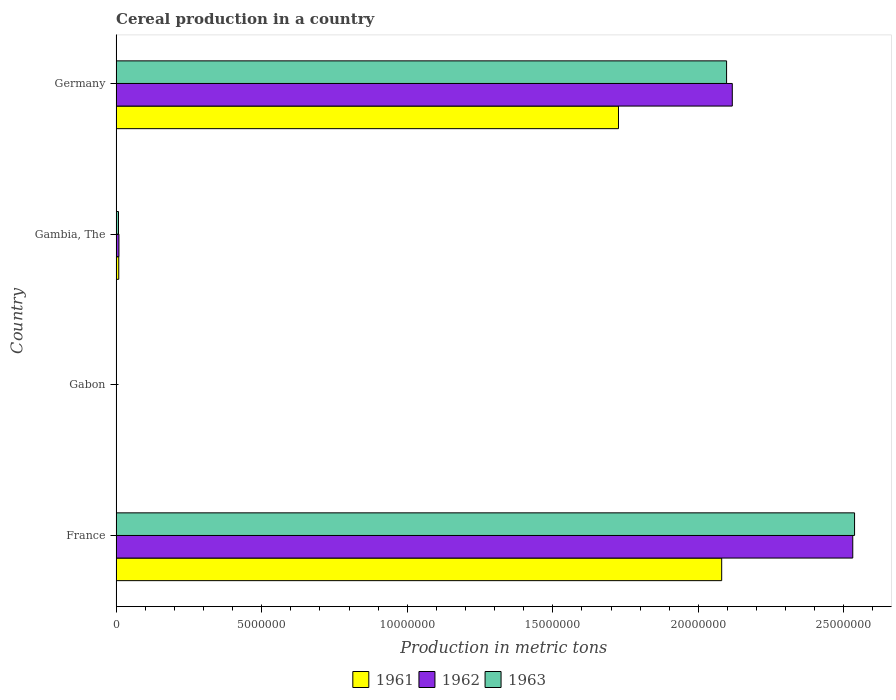How many different coloured bars are there?
Your answer should be compact. 3. Are the number of bars on each tick of the Y-axis equal?
Your answer should be very brief. Yes. How many bars are there on the 2nd tick from the top?
Ensure brevity in your answer.  3. How many bars are there on the 3rd tick from the bottom?
Offer a very short reply. 3. What is the total cereal production in 1963 in Germany?
Offer a very short reply. 2.10e+07. Across all countries, what is the maximum total cereal production in 1962?
Offer a very short reply. 2.53e+07. Across all countries, what is the minimum total cereal production in 1961?
Provide a short and direct response. 9285. In which country was the total cereal production in 1962 minimum?
Make the answer very short. Gabon. What is the total total cereal production in 1963 in the graph?
Offer a terse response. 4.64e+07. What is the difference between the total cereal production in 1961 in France and that in Gambia, The?
Ensure brevity in your answer.  2.07e+07. What is the difference between the total cereal production in 1963 in Germany and the total cereal production in 1961 in France?
Your response must be concise. 1.68e+05. What is the average total cereal production in 1961 per country?
Provide a succinct answer. 9.54e+06. What is the difference between the total cereal production in 1962 and total cereal production in 1963 in Germany?
Ensure brevity in your answer.  1.96e+05. What is the ratio of the total cereal production in 1961 in Gabon to that in Germany?
Keep it short and to the point. 0. Is the total cereal production in 1963 in Gambia, The less than that in Germany?
Ensure brevity in your answer.  Yes. Is the difference between the total cereal production in 1962 in Gabon and Germany greater than the difference between the total cereal production in 1963 in Gabon and Germany?
Provide a succinct answer. No. What is the difference between the highest and the second highest total cereal production in 1961?
Keep it short and to the point. 3.55e+06. What is the difference between the highest and the lowest total cereal production in 1962?
Offer a very short reply. 2.53e+07. Is the sum of the total cereal production in 1962 in France and Germany greater than the maximum total cereal production in 1963 across all countries?
Your answer should be very brief. Yes. What does the 2nd bar from the top in Gambia, The represents?
Your response must be concise. 1962. How many bars are there?
Provide a succinct answer. 12. Are all the bars in the graph horizontal?
Your answer should be compact. Yes. What is the difference between two consecutive major ticks on the X-axis?
Your answer should be compact. 5.00e+06. Where does the legend appear in the graph?
Give a very brief answer. Bottom center. What is the title of the graph?
Provide a succinct answer. Cereal production in a country. Does "1986" appear as one of the legend labels in the graph?
Keep it short and to the point. No. What is the label or title of the X-axis?
Offer a very short reply. Production in metric tons. What is the Production in metric tons of 1961 in France?
Offer a very short reply. 2.08e+07. What is the Production in metric tons in 1962 in France?
Offer a very short reply. 2.53e+07. What is the Production in metric tons in 1963 in France?
Your answer should be very brief. 2.54e+07. What is the Production in metric tons of 1961 in Gabon?
Provide a succinct answer. 9285. What is the Production in metric tons of 1962 in Gabon?
Ensure brevity in your answer.  9053. What is the Production in metric tons in 1963 in Gabon?
Offer a terse response. 9173. What is the Production in metric tons of 1961 in Gambia, The?
Give a very brief answer. 9.03e+04. What is the Production in metric tons of 1962 in Gambia, The?
Offer a terse response. 9.63e+04. What is the Production in metric tons in 1963 in Gambia, The?
Offer a very short reply. 8.16e+04. What is the Production in metric tons of 1961 in Germany?
Provide a succinct answer. 1.73e+07. What is the Production in metric tons of 1962 in Germany?
Provide a short and direct response. 2.12e+07. What is the Production in metric tons in 1963 in Germany?
Your response must be concise. 2.10e+07. Across all countries, what is the maximum Production in metric tons in 1961?
Keep it short and to the point. 2.08e+07. Across all countries, what is the maximum Production in metric tons of 1962?
Offer a terse response. 2.53e+07. Across all countries, what is the maximum Production in metric tons of 1963?
Your answer should be very brief. 2.54e+07. Across all countries, what is the minimum Production in metric tons of 1961?
Provide a succinct answer. 9285. Across all countries, what is the minimum Production in metric tons of 1962?
Ensure brevity in your answer.  9053. Across all countries, what is the minimum Production in metric tons in 1963?
Ensure brevity in your answer.  9173. What is the total Production in metric tons of 1961 in the graph?
Offer a terse response. 3.82e+07. What is the total Production in metric tons of 1962 in the graph?
Your answer should be compact. 4.66e+07. What is the total Production in metric tons of 1963 in the graph?
Offer a very short reply. 4.64e+07. What is the difference between the Production in metric tons of 1961 in France and that in Gabon?
Provide a short and direct response. 2.08e+07. What is the difference between the Production in metric tons in 1962 in France and that in Gabon?
Provide a succinct answer. 2.53e+07. What is the difference between the Production in metric tons in 1963 in France and that in Gabon?
Provide a short and direct response. 2.54e+07. What is the difference between the Production in metric tons of 1961 in France and that in Gambia, The?
Your answer should be compact. 2.07e+07. What is the difference between the Production in metric tons in 1962 in France and that in Gambia, The?
Provide a short and direct response. 2.52e+07. What is the difference between the Production in metric tons in 1963 in France and that in Gambia, The?
Provide a succinct answer. 2.53e+07. What is the difference between the Production in metric tons in 1961 in France and that in Germany?
Your answer should be compact. 3.55e+06. What is the difference between the Production in metric tons in 1962 in France and that in Germany?
Provide a succinct answer. 4.14e+06. What is the difference between the Production in metric tons of 1963 in France and that in Germany?
Offer a terse response. 4.40e+06. What is the difference between the Production in metric tons in 1961 in Gabon and that in Gambia, The?
Offer a very short reply. -8.10e+04. What is the difference between the Production in metric tons of 1962 in Gabon and that in Gambia, The?
Make the answer very short. -8.72e+04. What is the difference between the Production in metric tons of 1963 in Gabon and that in Gambia, The?
Your answer should be very brief. -7.24e+04. What is the difference between the Production in metric tons of 1961 in Gabon and that in Germany?
Ensure brevity in your answer.  -1.72e+07. What is the difference between the Production in metric tons in 1962 in Gabon and that in Germany?
Offer a terse response. -2.12e+07. What is the difference between the Production in metric tons of 1963 in Gabon and that in Germany?
Your answer should be very brief. -2.10e+07. What is the difference between the Production in metric tons in 1961 in Gambia, The and that in Germany?
Give a very brief answer. -1.72e+07. What is the difference between the Production in metric tons in 1962 in Gambia, The and that in Germany?
Make the answer very short. -2.11e+07. What is the difference between the Production in metric tons in 1963 in Gambia, The and that in Germany?
Make the answer very short. -2.09e+07. What is the difference between the Production in metric tons in 1961 in France and the Production in metric tons in 1962 in Gabon?
Make the answer very short. 2.08e+07. What is the difference between the Production in metric tons of 1961 in France and the Production in metric tons of 1963 in Gabon?
Keep it short and to the point. 2.08e+07. What is the difference between the Production in metric tons of 1962 in France and the Production in metric tons of 1963 in Gabon?
Give a very brief answer. 2.53e+07. What is the difference between the Production in metric tons of 1961 in France and the Production in metric tons of 1962 in Gambia, The?
Your response must be concise. 2.07e+07. What is the difference between the Production in metric tons of 1961 in France and the Production in metric tons of 1963 in Gambia, The?
Give a very brief answer. 2.07e+07. What is the difference between the Production in metric tons of 1962 in France and the Production in metric tons of 1963 in Gambia, The?
Ensure brevity in your answer.  2.52e+07. What is the difference between the Production in metric tons of 1961 in France and the Production in metric tons of 1962 in Germany?
Your response must be concise. -3.64e+05. What is the difference between the Production in metric tons of 1961 in France and the Production in metric tons of 1963 in Germany?
Your answer should be very brief. -1.68e+05. What is the difference between the Production in metric tons in 1962 in France and the Production in metric tons in 1963 in Germany?
Keep it short and to the point. 4.33e+06. What is the difference between the Production in metric tons in 1961 in Gabon and the Production in metric tons in 1962 in Gambia, The?
Your response must be concise. -8.70e+04. What is the difference between the Production in metric tons in 1961 in Gabon and the Production in metric tons in 1963 in Gambia, The?
Provide a short and direct response. -7.23e+04. What is the difference between the Production in metric tons of 1962 in Gabon and the Production in metric tons of 1963 in Gambia, The?
Make the answer very short. -7.25e+04. What is the difference between the Production in metric tons of 1961 in Gabon and the Production in metric tons of 1962 in Germany?
Your answer should be compact. -2.12e+07. What is the difference between the Production in metric tons in 1961 in Gabon and the Production in metric tons in 1963 in Germany?
Offer a terse response. -2.10e+07. What is the difference between the Production in metric tons of 1962 in Gabon and the Production in metric tons of 1963 in Germany?
Give a very brief answer. -2.10e+07. What is the difference between the Production in metric tons in 1961 in Gambia, The and the Production in metric tons in 1962 in Germany?
Offer a terse response. -2.11e+07. What is the difference between the Production in metric tons in 1961 in Gambia, The and the Production in metric tons in 1963 in Germany?
Ensure brevity in your answer.  -2.09e+07. What is the difference between the Production in metric tons of 1962 in Gambia, The and the Production in metric tons of 1963 in Germany?
Provide a succinct answer. -2.09e+07. What is the average Production in metric tons in 1961 per country?
Your response must be concise. 9.54e+06. What is the average Production in metric tons of 1962 per country?
Your response must be concise. 1.16e+07. What is the average Production in metric tons of 1963 per country?
Offer a terse response. 1.16e+07. What is the difference between the Production in metric tons of 1961 and Production in metric tons of 1962 in France?
Give a very brief answer. -4.50e+06. What is the difference between the Production in metric tons in 1961 and Production in metric tons in 1963 in France?
Give a very brief answer. -4.56e+06. What is the difference between the Production in metric tons in 1962 and Production in metric tons in 1963 in France?
Give a very brief answer. -6.22e+04. What is the difference between the Production in metric tons of 1961 and Production in metric tons of 1962 in Gabon?
Keep it short and to the point. 232. What is the difference between the Production in metric tons of 1961 and Production in metric tons of 1963 in Gabon?
Make the answer very short. 112. What is the difference between the Production in metric tons of 1962 and Production in metric tons of 1963 in Gabon?
Give a very brief answer. -120. What is the difference between the Production in metric tons in 1961 and Production in metric tons in 1962 in Gambia, The?
Provide a succinct answer. -5976. What is the difference between the Production in metric tons of 1961 and Production in metric tons of 1963 in Gambia, The?
Make the answer very short. 8726. What is the difference between the Production in metric tons in 1962 and Production in metric tons in 1963 in Gambia, The?
Give a very brief answer. 1.47e+04. What is the difference between the Production in metric tons of 1961 and Production in metric tons of 1962 in Germany?
Offer a very short reply. -3.91e+06. What is the difference between the Production in metric tons of 1961 and Production in metric tons of 1963 in Germany?
Provide a short and direct response. -3.71e+06. What is the difference between the Production in metric tons in 1962 and Production in metric tons in 1963 in Germany?
Offer a very short reply. 1.96e+05. What is the ratio of the Production in metric tons in 1961 in France to that in Gabon?
Provide a succinct answer. 2240.44. What is the ratio of the Production in metric tons of 1962 in France to that in Gabon?
Offer a very short reply. 2795.22. What is the ratio of the Production in metric tons of 1963 in France to that in Gabon?
Offer a terse response. 2765.43. What is the ratio of the Production in metric tons of 1961 in France to that in Gambia, The?
Your response must be concise. 230.31. What is the ratio of the Production in metric tons in 1962 in France to that in Gambia, The?
Your answer should be very brief. 262.78. What is the ratio of the Production in metric tons in 1963 in France to that in Gambia, The?
Your answer should be compact. 310.89. What is the ratio of the Production in metric tons in 1961 in France to that in Germany?
Your answer should be compact. 1.21. What is the ratio of the Production in metric tons in 1962 in France to that in Germany?
Your answer should be very brief. 1.2. What is the ratio of the Production in metric tons of 1963 in France to that in Germany?
Provide a short and direct response. 1.21. What is the ratio of the Production in metric tons in 1961 in Gabon to that in Gambia, The?
Keep it short and to the point. 0.1. What is the ratio of the Production in metric tons of 1962 in Gabon to that in Gambia, The?
Provide a succinct answer. 0.09. What is the ratio of the Production in metric tons in 1963 in Gabon to that in Gambia, The?
Ensure brevity in your answer.  0.11. What is the ratio of the Production in metric tons in 1961 in Gabon to that in Germany?
Your answer should be very brief. 0. What is the ratio of the Production in metric tons in 1961 in Gambia, The to that in Germany?
Ensure brevity in your answer.  0.01. What is the ratio of the Production in metric tons of 1962 in Gambia, The to that in Germany?
Ensure brevity in your answer.  0. What is the ratio of the Production in metric tons in 1963 in Gambia, The to that in Germany?
Provide a short and direct response. 0. What is the difference between the highest and the second highest Production in metric tons of 1961?
Make the answer very short. 3.55e+06. What is the difference between the highest and the second highest Production in metric tons in 1962?
Make the answer very short. 4.14e+06. What is the difference between the highest and the second highest Production in metric tons of 1963?
Your response must be concise. 4.40e+06. What is the difference between the highest and the lowest Production in metric tons in 1961?
Offer a terse response. 2.08e+07. What is the difference between the highest and the lowest Production in metric tons of 1962?
Your answer should be very brief. 2.53e+07. What is the difference between the highest and the lowest Production in metric tons in 1963?
Provide a succinct answer. 2.54e+07. 